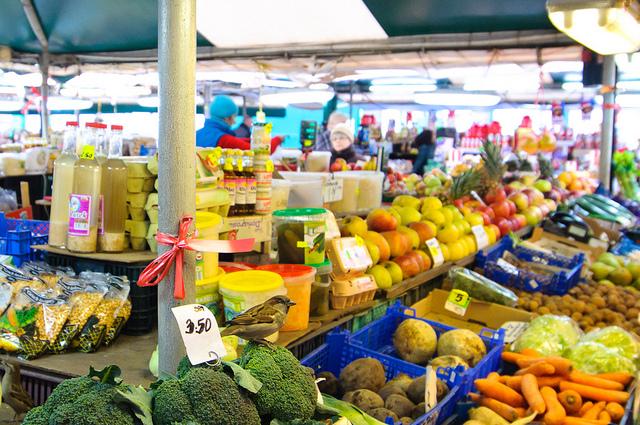Are these foods generally considered healthy?
Concise answer only. Yes. Do all bins contain vegetables?
Write a very short answer. Yes. Are there many customers at this vegetable market?
Short answer required. No. Is this a market?
Be succinct. Yes. Is this in America?
Be succinct. No. What color are the bins holding the vegetables?
Write a very short answer. Blue. What is the purpose of this tent?
Give a very brief answer. Food. 